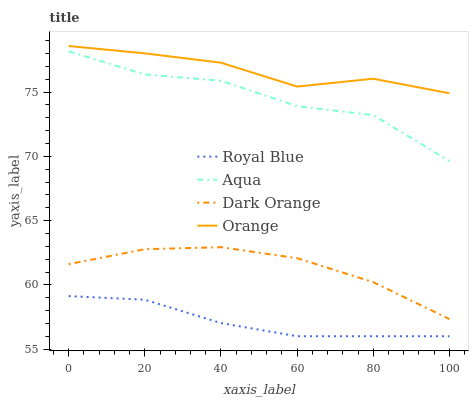Does Royal Blue have the minimum area under the curve?
Answer yes or no. Yes. Does Orange have the maximum area under the curve?
Answer yes or no. Yes. Does Aqua have the minimum area under the curve?
Answer yes or no. No. Does Aqua have the maximum area under the curve?
Answer yes or no. No. Is Royal Blue the smoothest?
Answer yes or no. Yes. Is Aqua the roughest?
Answer yes or no. Yes. Is Aqua the smoothest?
Answer yes or no. No. Is Royal Blue the roughest?
Answer yes or no. No. Does Royal Blue have the lowest value?
Answer yes or no. Yes. Does Aqua have the lowest value?
Answer yes or no. No. Does Orange have the highest value?
Answer yes or no. Yes. Does Aqua have the highest value?
Answer yes or no. No. Is Aqua less than Orange?
Answer yes or no. Yes. Is Aqua greater than Dark Orange?
Answer yes or no. Yes. Does Aqua intersect Orange?
Answer yes or no. No. 